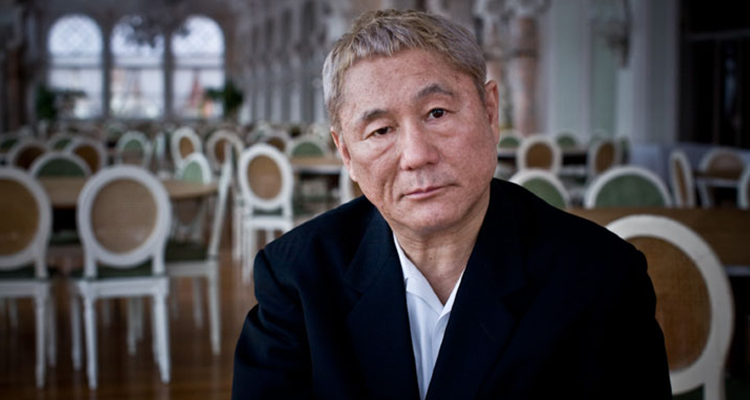Explain the visual content of the image in great detail. This image features an older male subject with silver hair and a somber expression, dressed in a formal black suit. He is seated, facing slightly towards the camera, giving an impression of deep thought or contemplation. The setting is an indoor space, likely a restaurant, indicated by multiple empty tables and white chairs arranged around. These are meticulously set against large windows, allowing ample natural light to fill the room. His serious demeanor, contrasted with the open, neutrally-colored space, creates a poignant atmosphere. The tones are muted, with dominant grays and whites highlighting the subject's dark attire. Overall, the scene conveys a quiet moment of reflection in a public yet tranquil setting. 